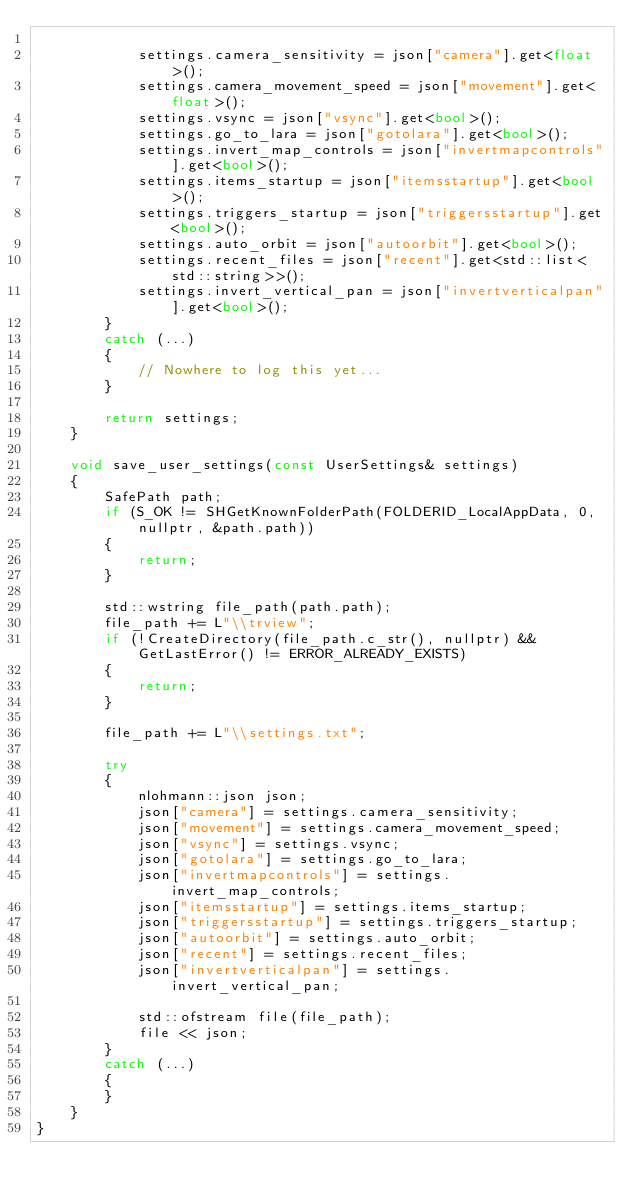<code> <loc_0><loc_0><loc_500><loc_500><_C++_>
            settings.camera_sensitivity = json["camera"].get<float>();
            settings.camera_movement_speed = json["movement"].get<float>();
            settings.vsync = json["vsync"].get<bool>();
            settings.go_to_lara = json["gotolara"].get<bool>();
            settings.invert_map_controls = json["invertmapcontrols"].get<bool>();
            settings.items_startup = json["itemsstartup"].get<bool>();
            settings.triggers_startup = json["triggersstartup"].get<bool>();
            settings.auto_orbit = json["autoorbit"].get<bool>();
            settings.recent_files = json["recent"].get<std::list<std::string>>();
            settings.invert_vertical_pan = json["invertverticalpan"].get<bool>();
        }
        catch (...)
        {
            // Nowhere to log this yet...
        }

        return settings;
    }

    void save_user_settings(const UserSettings& settings)
    {
        SafePath path;
        if (S_OK != SHGetKnownFolderPath(FOLDERID_LocalAppData, 0, nullptr, &path.path))
        {
            return;
        }

        std::wstring file_path(path.path);
        file_path += L"\\trview";
        if (!CreateDirectory(file_path.c_str(), nullptr) && GetLastError() != ERROR_ALREADY_EXISTS)
        {
            return;
        }

        file_path += L"\\settings.txt";

        try
        {
            nlohmann::json json;
            json["camera"] = settings.camera_sensitivity;
            json["movement"] = settings.camera_movement_speed;
            json["vsync"] = settings.vsync;
            json["gotolara"] = settings.go_to_lara;
            json["invertmapcontrols"] = settings.invert_map_controls;
            json["itemsstartup"] = settings.items_startup;
            json["triggersstartup"] = settings.triggers_startup;
            json["autoorbit"] = settings.auto_orbit;
            json["recent"] = settings.recent_files;
            json["invertverticalpan"] = settings.invert_vertical_pan;

            std::ofstream file(file_path);
            file << json;
        }
        catch (...)
        {
        }
    }
}
</code> 